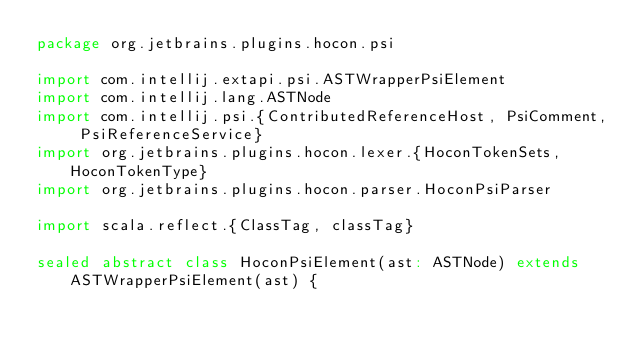<code> <loc_0><loc_0><loc_500><loc_500><_Scala_>package org.jetbrains.plugins.hocon.psi

import com.intellij.extapi.psi.ASTWrapperPsiElement
import com.intellij.lang.ASTNode
import com.intellij.psi.{ContributedReferenceHost, PsiComment, PsiReferenceService}
import org.jetbrains.plugins.hocon.lexer.{HoconTokenSets, HoconTokenType}
import org.jetbrains.plugins.hocon.parser.HoconPsiParser

import scala.reflect.{ClassTag, classTag}

sealed abstract class HoconPsiElement(ast: ASTNode) extends ASTWrapperPsiElement(ast) {</code> 